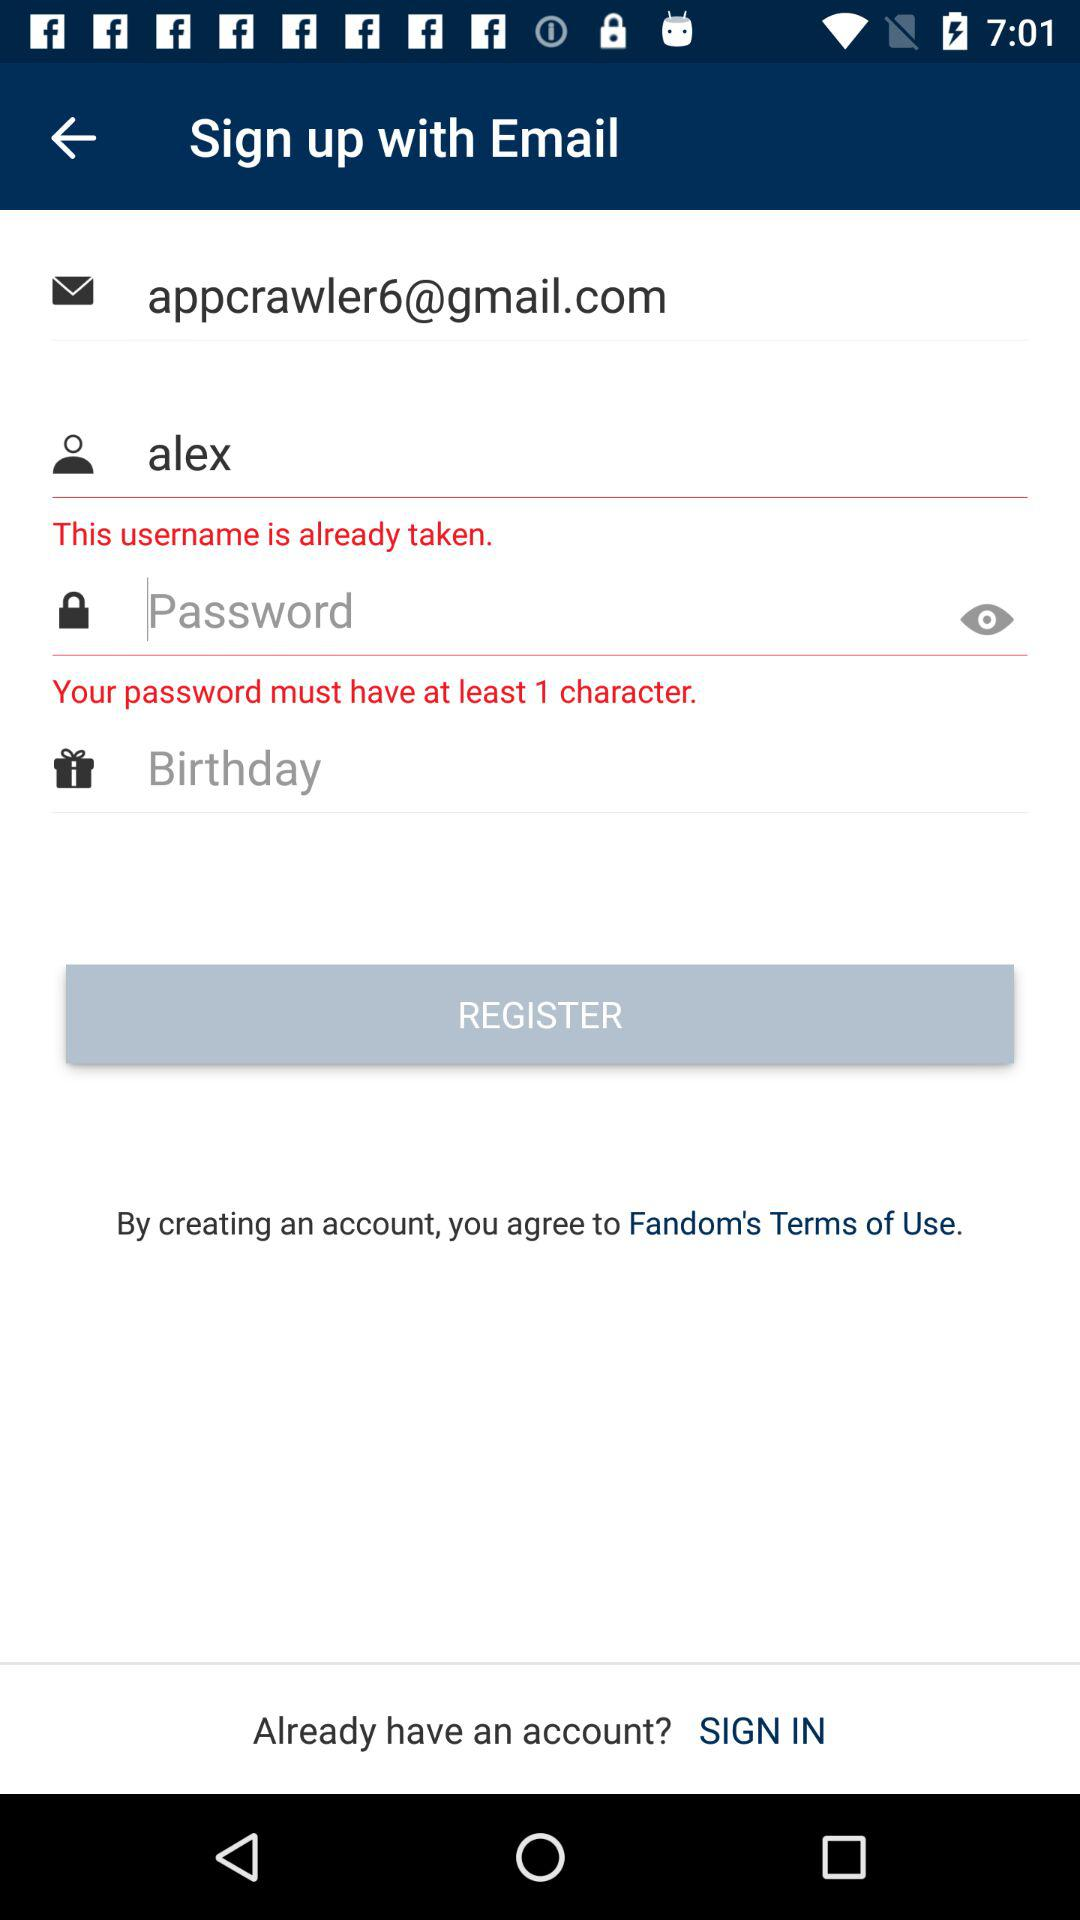What is the name of the user? The name of the user is Alex. 